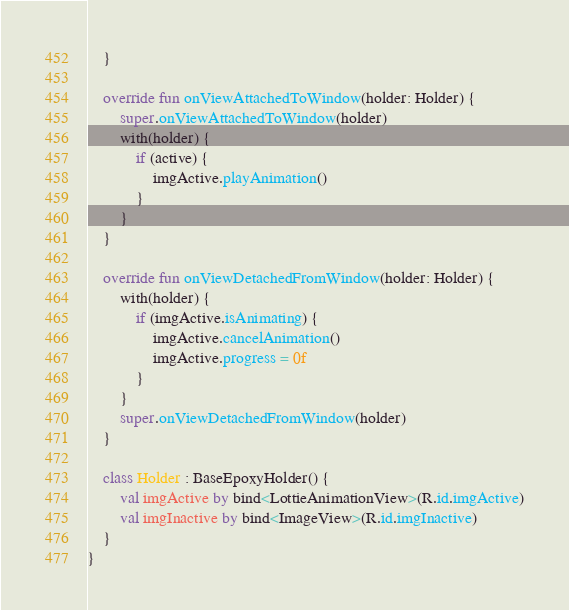<code> <loc_0><loc_0><loc_500><loc_500><_Kotlin_>    }

    override fun onViewAttachedToWindow(holder: Holder) {
        super.onViewAttachedToWindow(holder)
        with(holder) {
            if (active) {
                imgActive.playAnimation()
            }
        }
    }

    override fun onViewDetachedFromWindow(holder: Holder) {
        with(holder) {
            if (imgActive.isAnimating) {
                imgActive.cancelAnimation()
                imgActive.progress = 0f
            }
        }
        super.onViewDetachedFromWindow(holder)
    }

    class Holder : BaseEpoxyHolder() {
        val imgActive by bind<LottieAnimationView>(R.id.imgActive)
        val imgInactive by bind<ImageView>(R.id.imgInactive)
    }
}</code> 